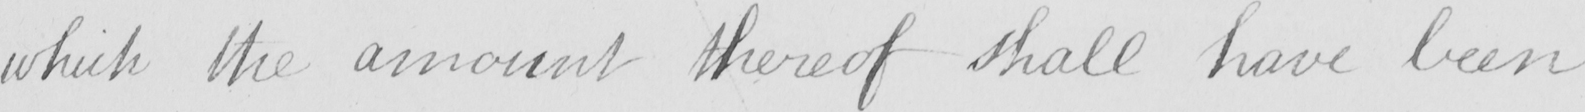Please transcribe the handwritten text in this image. which the amount thereof shall have been 